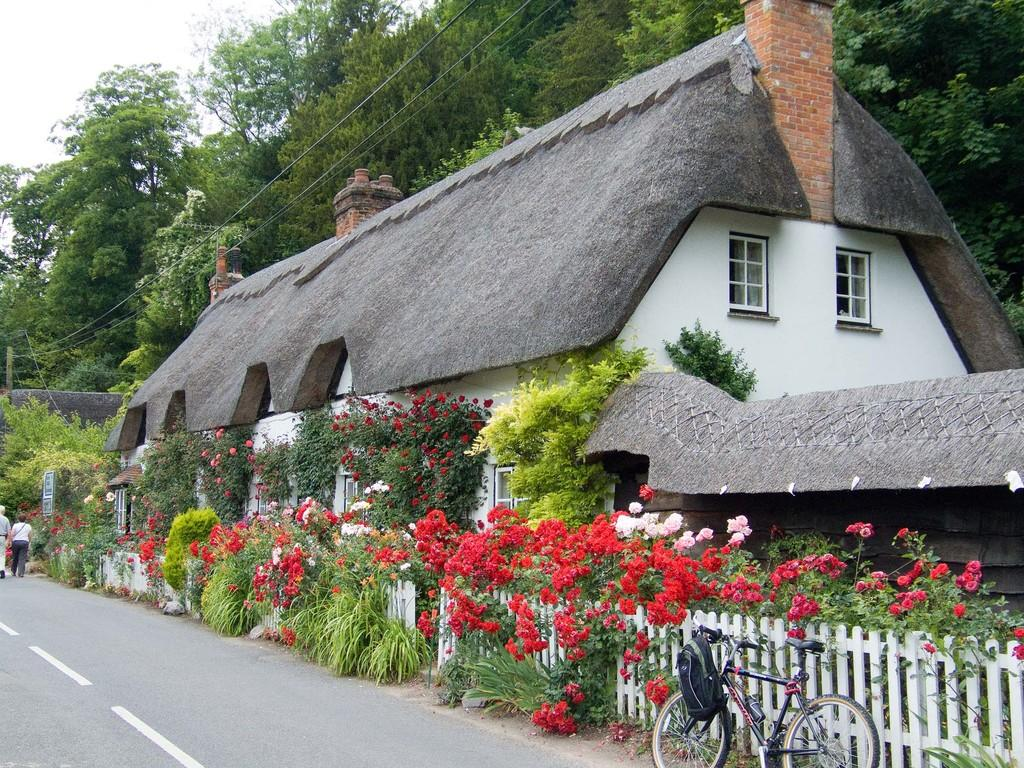What is the main object in the image? There is a bicycle in the image. What else can be seen in the image besides the bicycle? There is a bag, flowers, a building with windows, trees, and two people walking on the road in the image. Can you describe the building in the image? The building has windows. What is visible in the background of the image? The sky with clouds is visible in the background of the image. What type of ship can be seen sailing in the background of the image? There is no ship present in the image; it features a bicycle, a bag, flowers, a building with windows, trees, two people walking, and a sky with clouds in the background. 